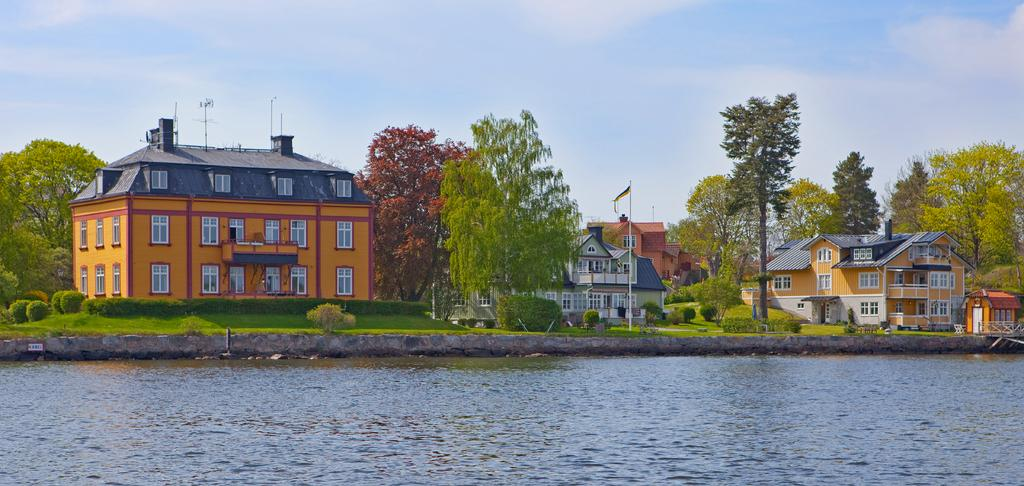What natural element can be seen in the image? Water is visible in the image. What type of vegetation is present in the image? There is grass, plants, and trees in the image. What man-made object can be seen in the image? There is a flag with a pole in the image. What structures are visible in the image? There are buildings in the image. What part of the natural environment is visible in the image? The sky is visible in the image. What atmospheric feature can be seen in the sky? Clouds are present in the sky. What invention can be seen in the image? There is no specific invention present in the image. What type of voice can be heard coming from the trees in the image? There is no sound or voice present in the image, as it is a still image. 